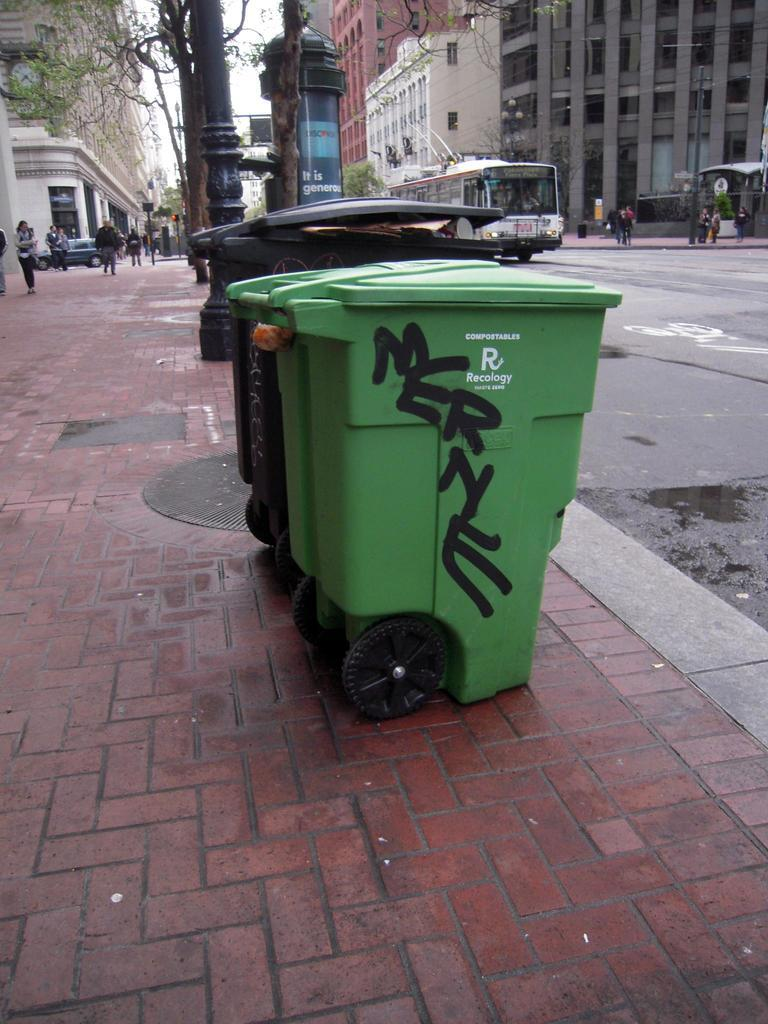<image>
Relay a brief, clear account of the picture shown. Refuse cans one green on a streetscape tagged with spray painted word MERNE 